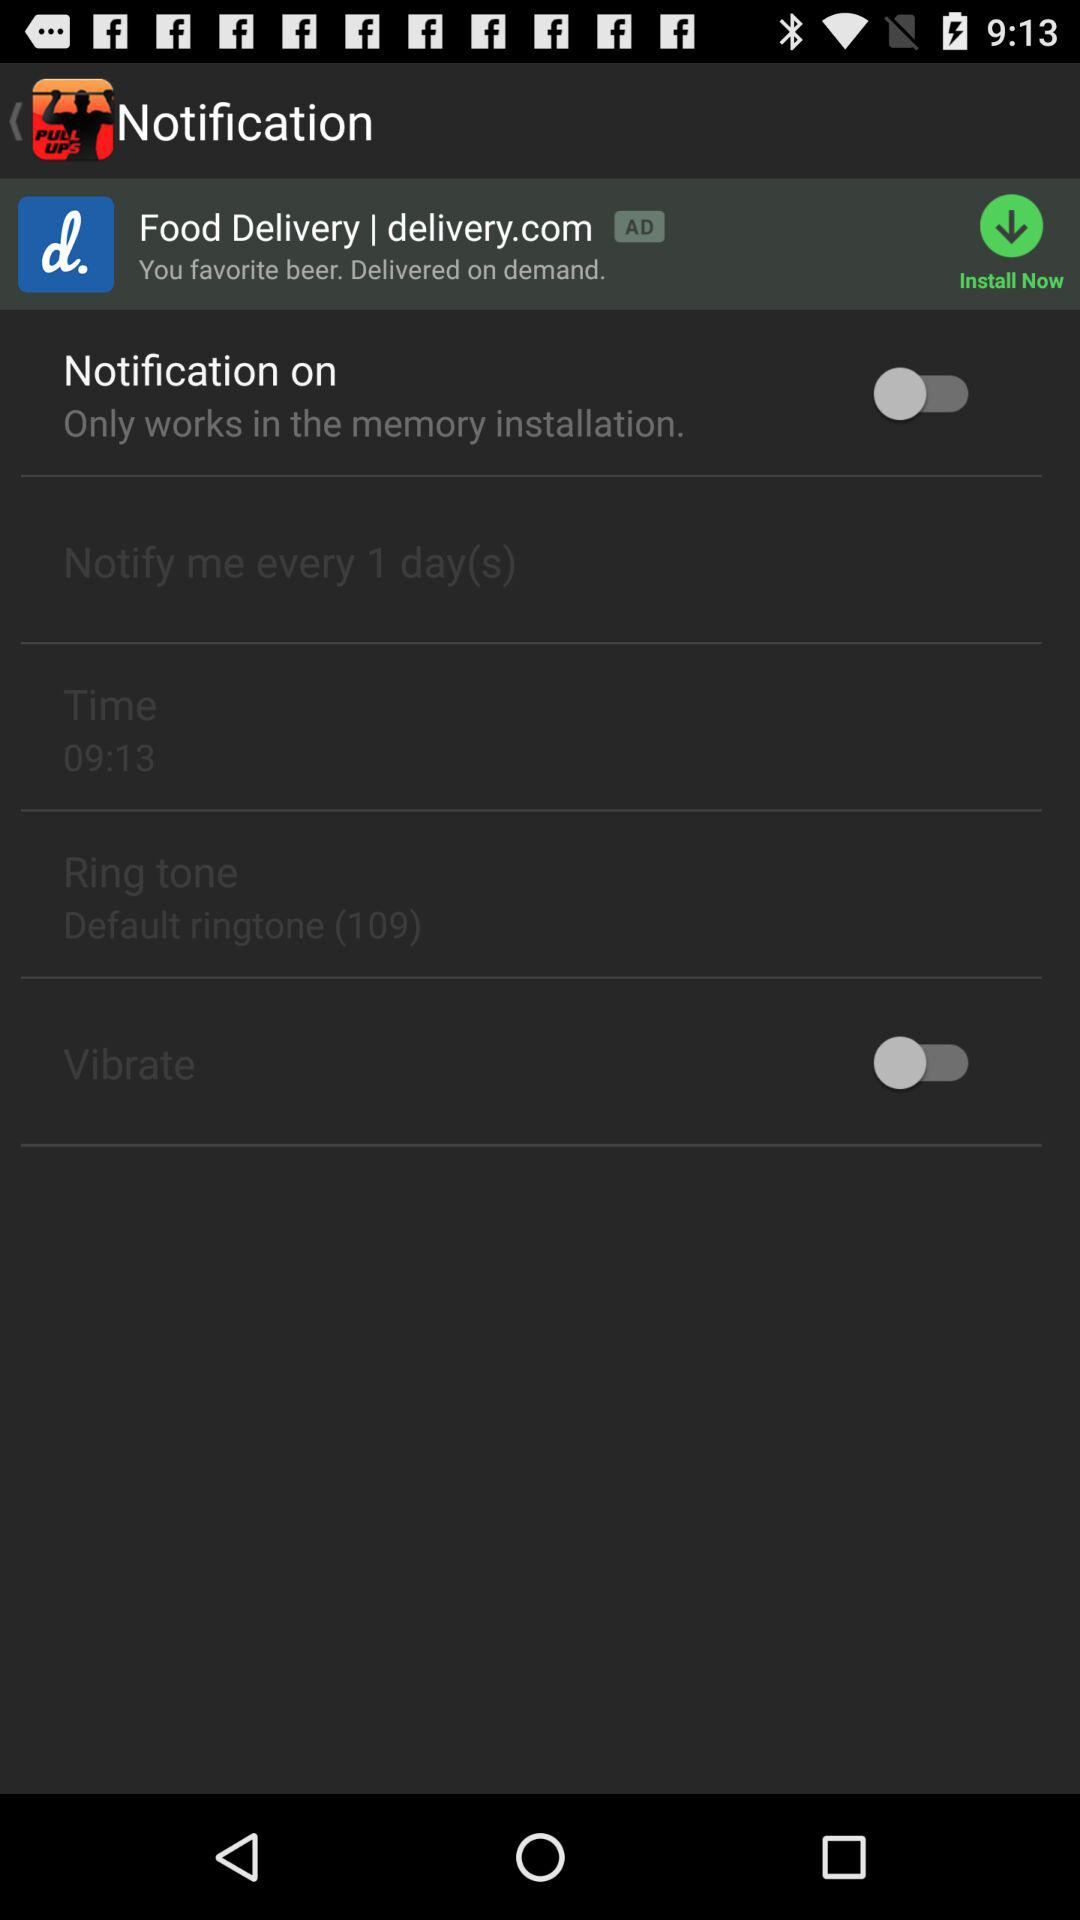What is the status of "Notification on"? The status is "off". 